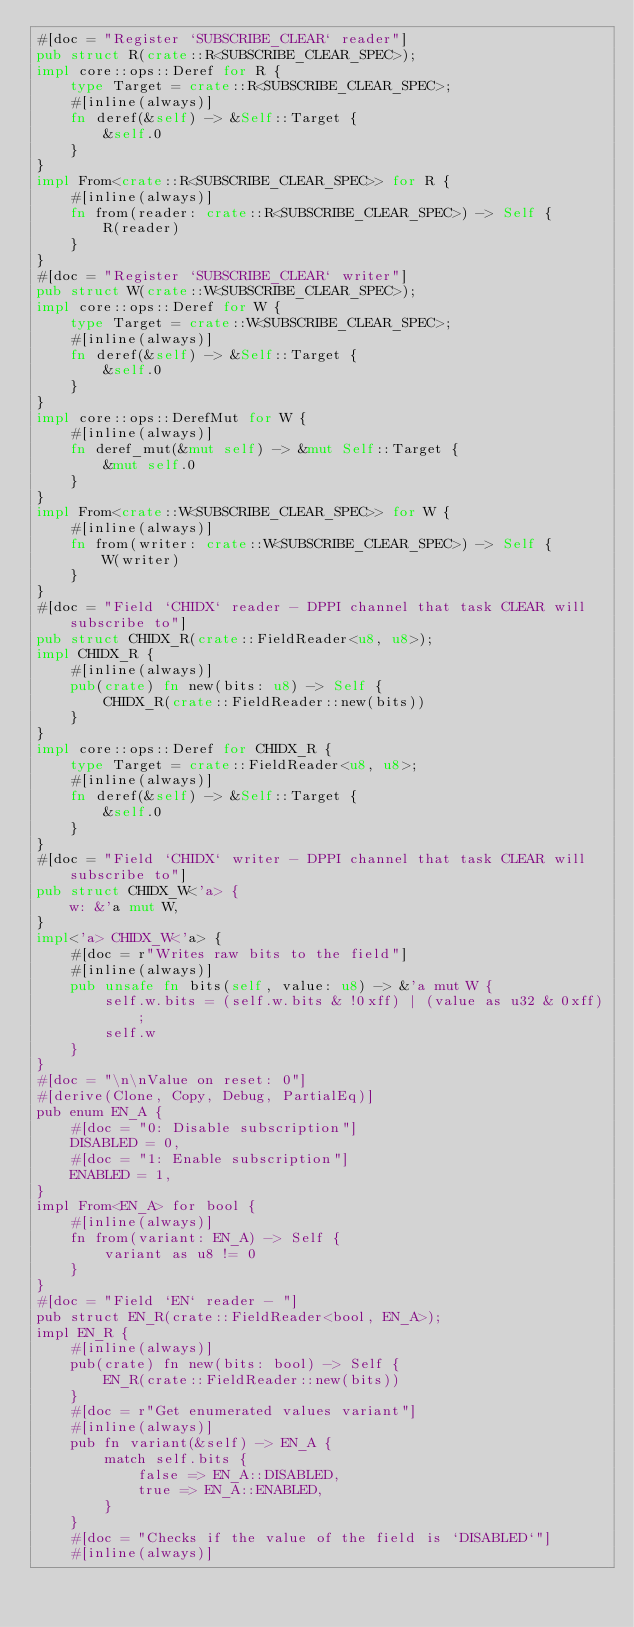<code> <loc_0><loc_0><loc_500><loc_500><_Rust_>#[doc = "Register `SUBSCRIBE_CLEAR` reader"]
pub struct R(crate::R<SUBSCRIBE_CLEAR_SPEC>);
impl core::ops::Deref for R {
    type Target = crate::R<SUBSCRIBE_CLEAR_SPEC>;
    #[inline(always)]
    fn deref(&self) -> &Self::Target {
        &self.0
    }
}
impl From<crate::R<SUBSCRIBE_CLEAR_SPEC>> for R {
    #[inline(always)]
    fn from(reader: crate::R<SUBSCRIBE_CLEAR_SPEC>) -> Self {
        R(reader)
    }
}
#[doc = "Register `SUBSCRIBE_CLEAR` writer"]
pub struct W(crate::W<SUBSCRIBE_CLEAR_SPEC>);
impl core::ops::Deref for W {
    type Target = crate::W<SUBSCRIBE_CLEAR_SPEC>;
    #[inline(always)]
    fn deref(&self) -> &Self::Target {
        &self.0
    }
}
impl core::ops::DerefMut for W {
    #[inline(always)]
    fn deref_mut(&mut self) -> &mut Self::Target {
        &mut self.0
    }
}
impl From<crate::W<SUBSCRIBE_CLEAR_SPEC>> for W {
    #[inline(always)]
    fn from(writer: crate::W<SUBSCRIBE_CLEAR_SPEC>) -> Self {
        W(writer)
    }
}
#[doc = "Field `CHIDX` reader - DPPI channel that task CLEAR will subscribe to"]
pub struct CHIDX_R(crate::FieldReader<u8, u8>);
impl CHIDX_R {
    #[inline(always)]
    pub(crate) fn new(bits: u8) -> Self {
        CHIDX_R(crate::FieldReader::new(bits))
    }
}
impl core::ops::Deref for CHIDX_R {
    type Target = crate::FieldReader<u8, u8>;
    #[inline(always)]
    fn deref(&self) -> &Self::Target {
        &self.0
    }
}
#[doc = "Field `CHIDX` writer - DPPI channel that task CLEAR will subscribe to"]
pub struct CHIDX_W<'a> {
    w: &'a mut W,
}
impl<'a> CHIDX_W<'a> {
    #[doc = r"Writes raw bits to the field"]
    #[inline(always)]
    pub unsafe fn bits(self, value: u8) -> &'a mut W {
        self.w.bits = (self.w.bits & !0xff) | (value as u32 & 0xff);
        self.w
    }
}
#[doc = "\n\nValue on reset: 0"]
#[derive(Clone, Copy, Debug, PartialEq)]
pub enum EN_A {
    #[doc = "0: Disable subscription"]
    DISABLED = 0,
    #[doc = "1: Enable subscription"]
    ENABLED = 1,
}
impl From<EN_A> for bool {
    #[inline(always)]
    fn from(variant: EN_A) -> Self {
        variant as u8 != 0
    }
}
#[doc = "Field `EN` reader - "]
pub struct EN_R(crate::FieldReader<bool, EN_A>);
impl EN_R {
    #[inline(always)]
    pub(crate) fn new(bits: bool) -> Self {
        EN_R(crate::FieldReader::new(bits))
    }
    #[doc = r"Get enumerated values variant"]
    #[inline(always)]
    pub fn variant(&self) -> EN_A {
        match self.bits {
            false => EN_A::DISABLED,
            true => EN_A::ENABLED,
        }
    }
    #[doc = "Checks if the value of the field is `DISABLED`"]
    #[inline(always)]</code> 